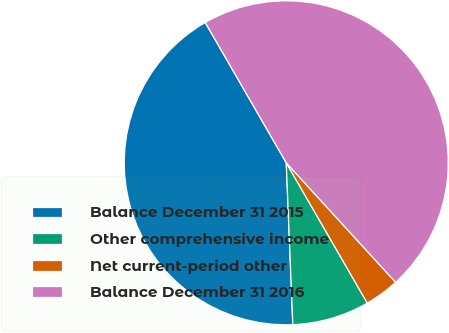Convert chart. <chart><loc_0><loc_0><loc_500><loc_500><pie_chart><fcel>Balance December 31 2015<fcel>Other comprehensive income<fcel>Net current-period other<fcel>Balance December 31 2016<nl><fcel>42.31%<fcel>7.69%<fcel>3.46%<fcel>46.54%<nl></chart> 